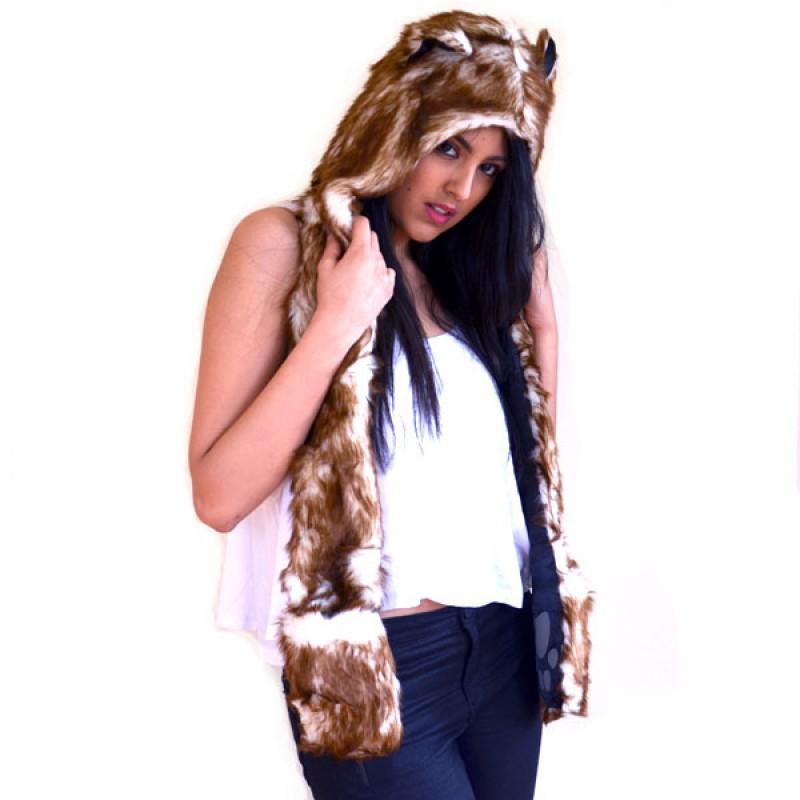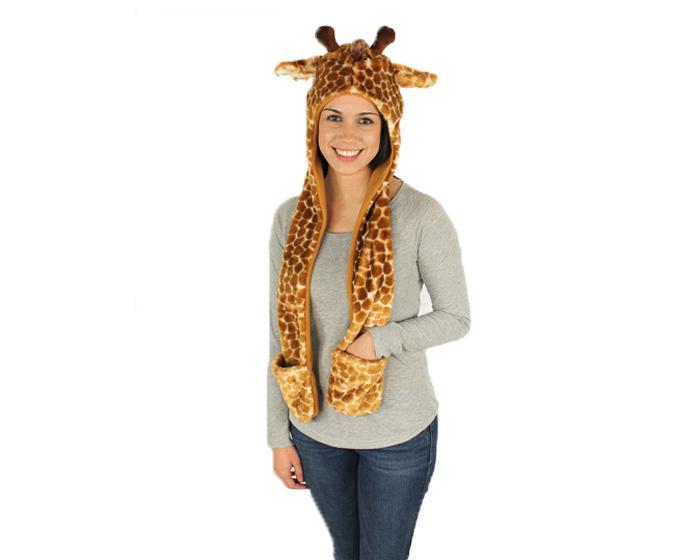The first image is the image on the left, the second image is the image on the right. For the images shown, is this caption "At least one of the hats has a giraffe print." true? Answer yes or no. Yes. The first image is the image on the left, the second image is the image on the right. Examine the images to the left and right. Is the description "a person has one hand tucked in a hat pocket" accurate? Answer yes or no. Yes. 